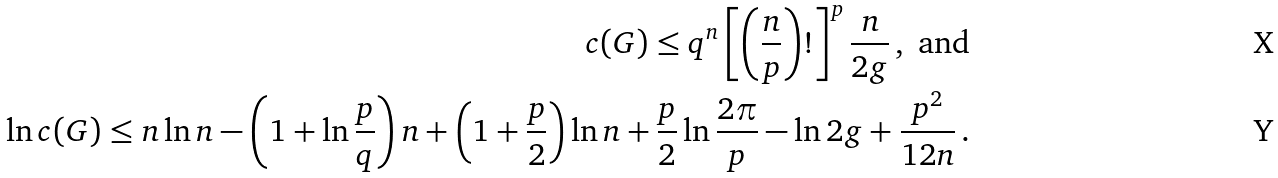Convert formula to latex. <formula><loc_0><loc_0><loc_500><loc_500>c ( G ) \leq q ^ { n } \left [ \left ( \frac { n } { p } \right ) ! \right ] ^ { p } \frac { n } { 2 g } \, , \text { and} \\ \ln c ( G ) \leq n \ln n - \left ( 1 + \ln \frac { p } { q } \right ) n + \left ( 1 + \frac { p } { 2 } \right ) \ln n + \frac { p } { 2 } \ln \frac { 2 \pi } { p } - \ln 2 g + \frac { p ^ { 2 } } { 1 2 n } \, .</formula> 